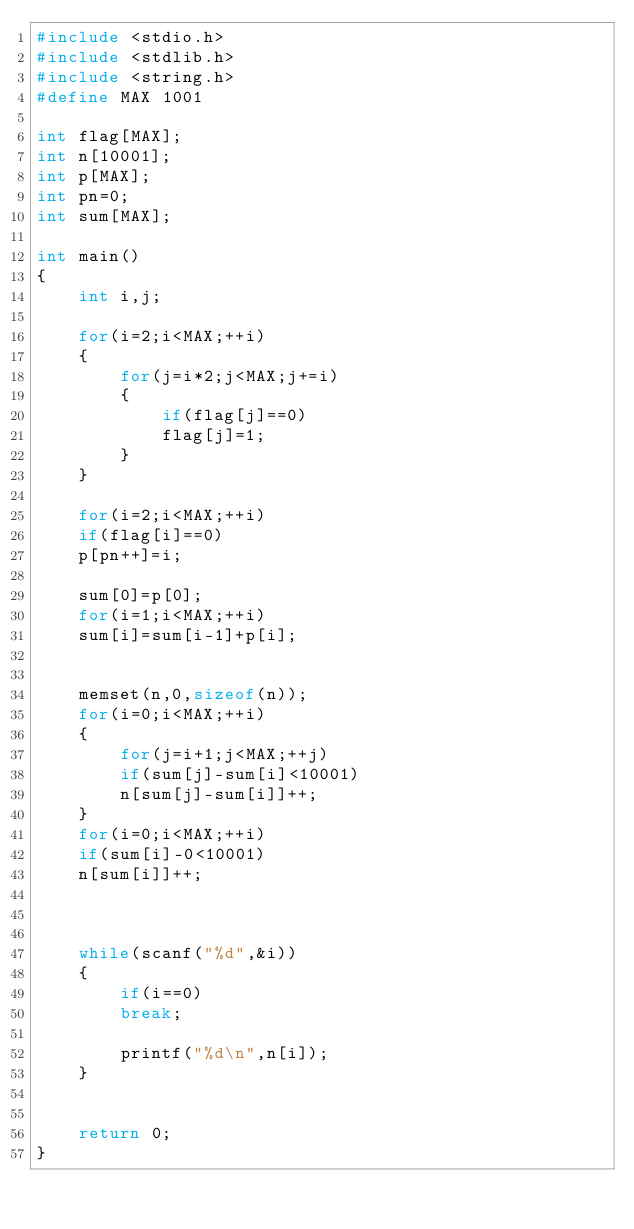Convert code to text. <code><loc_0><loc_0><loc_500><loc_500><_C_>#include <stdio.h>
#include <stdlib.h>
#include <string.h>
#define MAX 1001

int flag[MAX];
int n[10001];
int p[MAX];
int pn=0;
int sum[MAX];

int main()
{
    int i,j;

    for(i=2;i<MAX;++i)
    {
        for(j=i*2;j<MAX;j+=i)
        {
            if(flag[j]==0)
            flag[j]=1;
        }
    }

    for(i=2;i<MAX;++i)
    if(flag[i]==0)
    p[pn++]=i;

    sum[0]=p[0];
    for(i=1;i<MAX;++i)
    sum[i]=sum[i-1]+p[i];


    memset(n,0,sizeof(n));
    for(i=0;i<MAX;++i)
    {
        for(j=i+1;j<MAX;++j)
        if(sum[j]-sum[i]<10001)
        n[sum[j]-sum[i]]++;
    }
    for(i=0;i<MAX;++i)
    if(sum[i]-0<10001)
    n[sum[i]]++;



    while(scanf("%d",&i))
    {
        if(i==0)
        break;

        printf("%d\n",n[i]);
    }


    return 0;
}</code> 